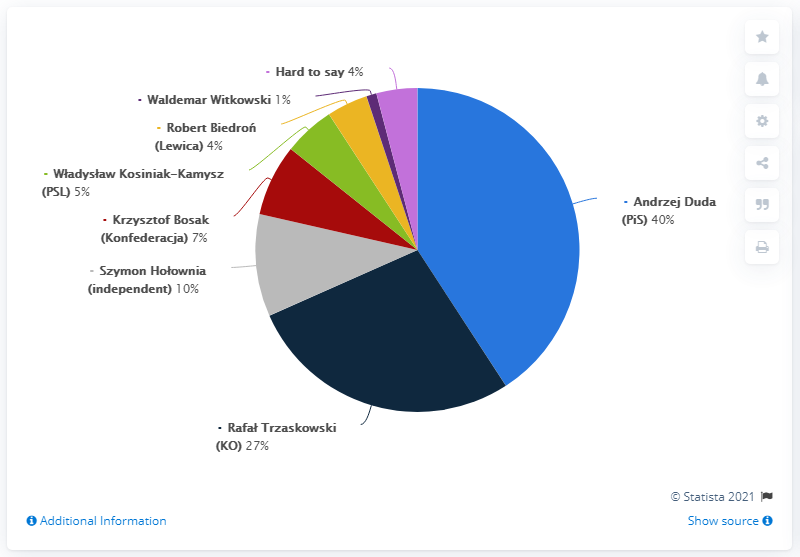Identify some key points in this picture. According to the survey responses, 27% of respondents supported Rafa Trzaskowski. 